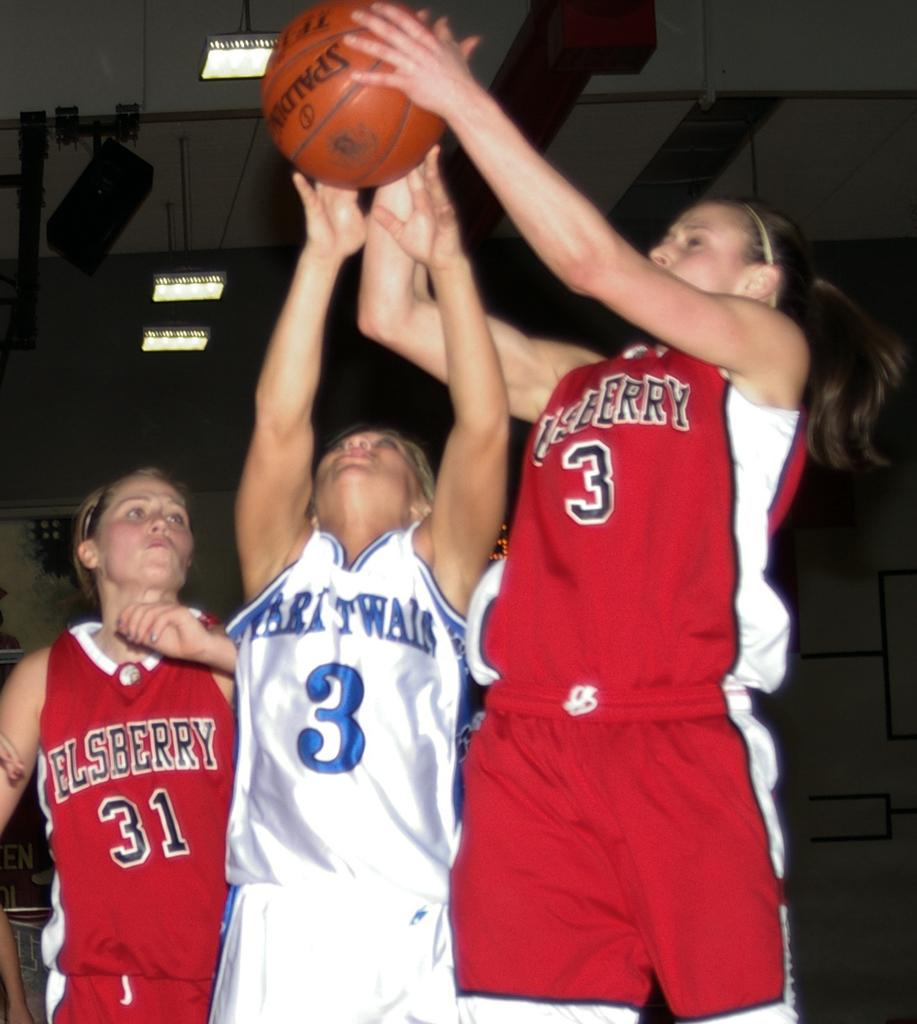How many women are playing basketball in the image? There are three women in the image. What are the women wearing while playing basketball? The women are wearing jerseys. What colors are the jerseys? The jerseys are in white and red color. What can be seen above the basketball court in the image? There is a roof visible in the image. Can you see any beads rolling on the basketball court in the image? There are no beads present in the image, and therefore no such activity can be observed. 